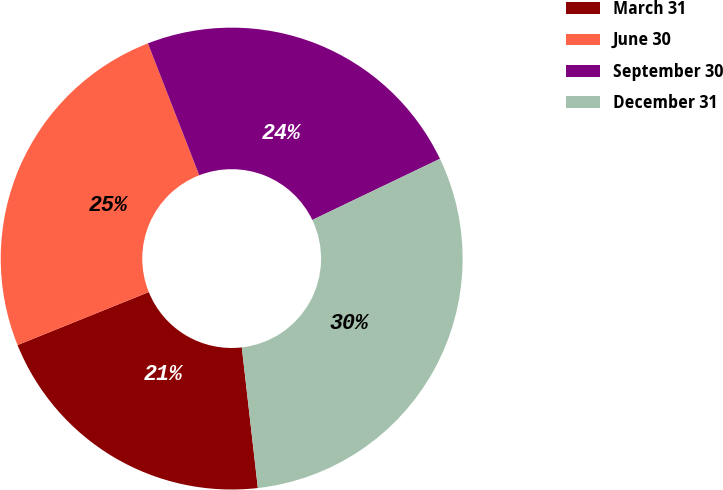Convert chart. <chart><loc_0><loc_0><loc_500><loc_500><pie_chart><fcel>March 31<fcel>June 30<fcel>September 30<fcel>December 31<nl><fcel>20.7%<fcel>25.2%<fcel>23.8%<fcel>30.3%<nl></chart> 